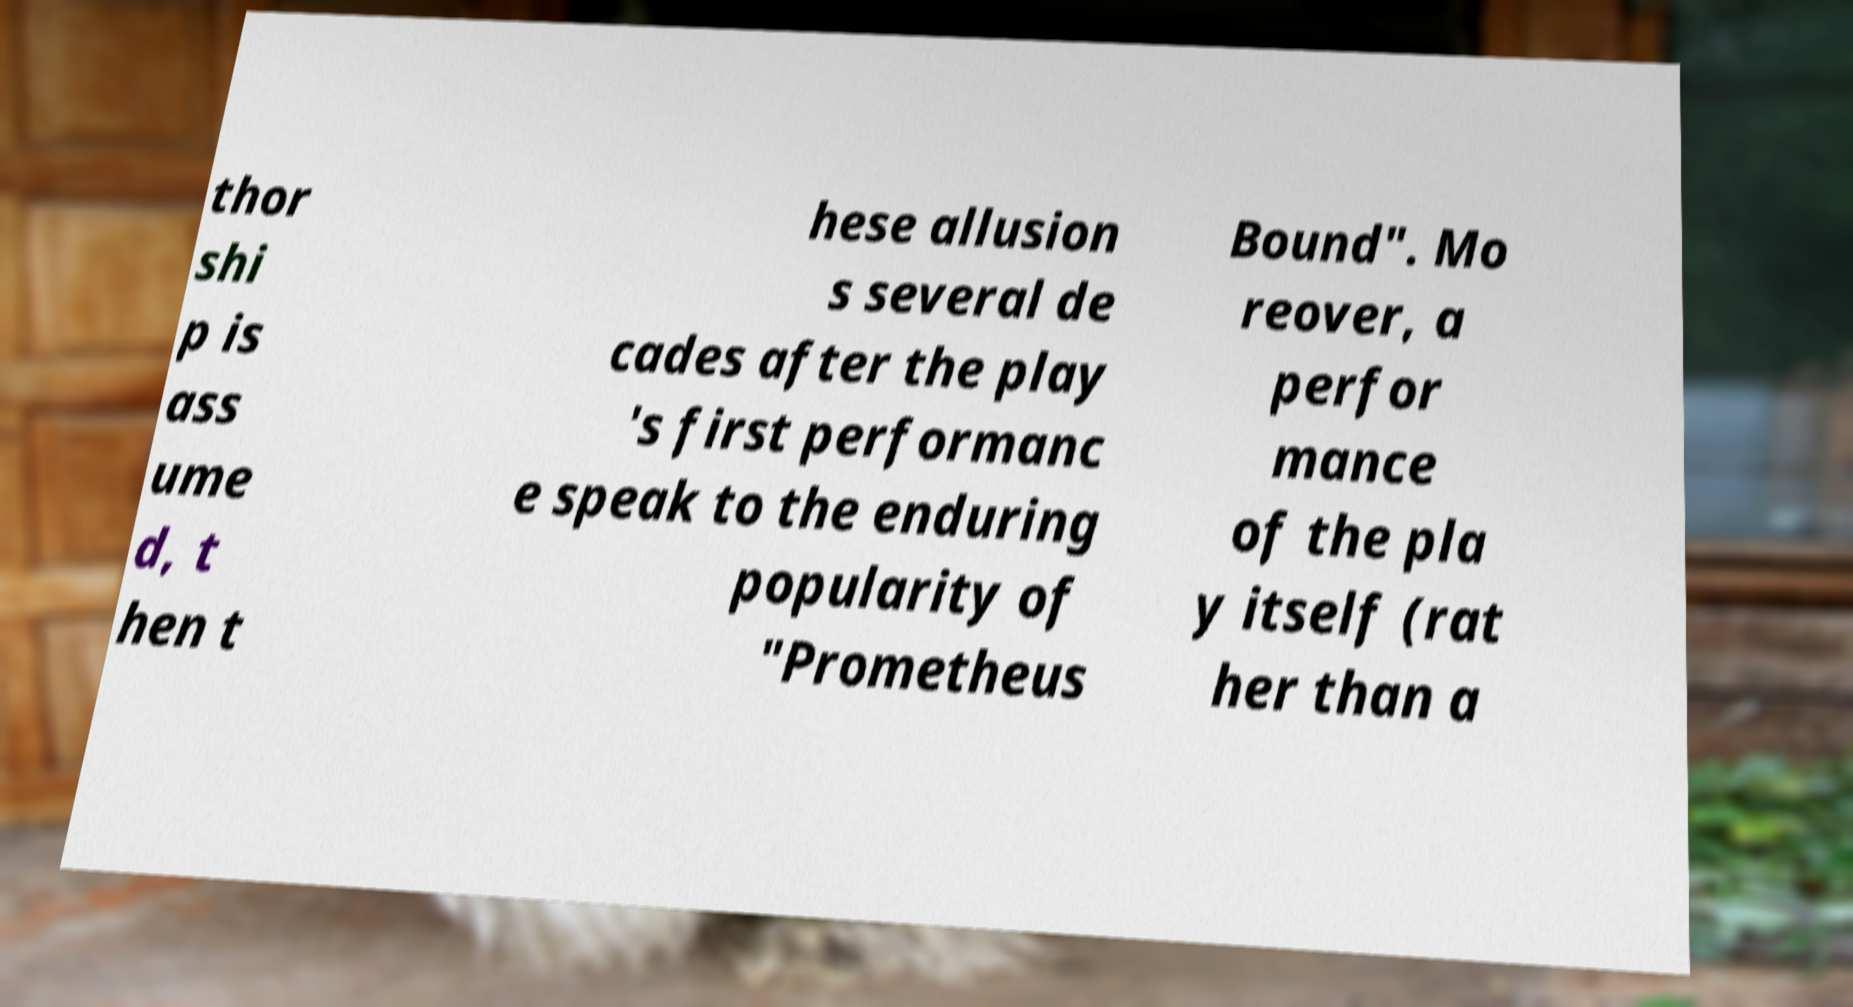Please identify and transcribe the text found in this image. thor shi p is ass ume d, t hen t hese allusion s several de cades after the play 's first performanc e speak to the enduring popularity of "Prometheus Bound". Mo reover, a perfor mance of the pla y itself (rat her than a 